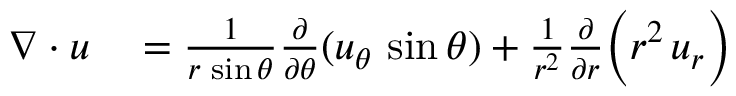Convert formula to latex. <formula><loc_0><loc_0><loc_500><loc_500>\begin{array} { r l } { \nabla \cdot { u } } & = { \frac { 1 } { r \, \sin \theta } } { \frac { \partial } { \partial \theta } } ( u _ { \theta } \, \sin \theta ) + { \frac { 1 } { r ^ { 2 } } } { \frac { \partial } { \partial r } } { \left ( } r ^ { 2 } \, u _ { r } { \right ) } } \end{array}</formula> 